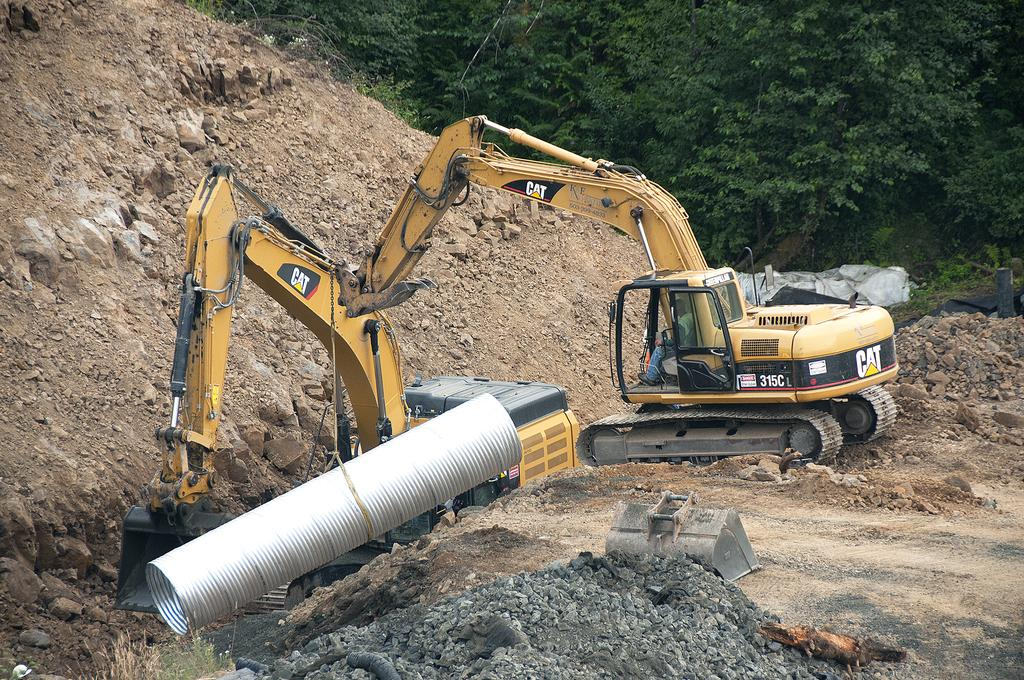What are the main subjects in the image? There are two cranes in the image. What is one of the cranes doing? One crane is holding an is holding an object. What type of surface can be seen in the background of the image? There is a sand surface in the background of the image. What can be seen at the top of the image? There are trees visible at the top of the image. What type of birds are flying around the cranes in the image? There are no birds visible in the image; it only features two cranes and a sand surface in the background. 